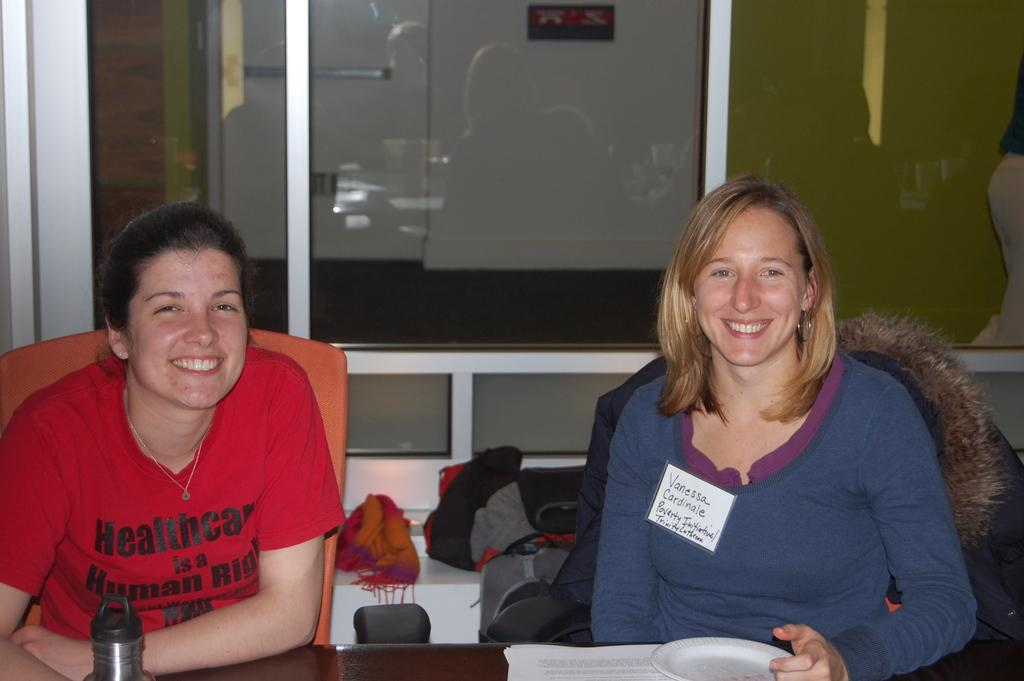How many people are in the image? There are two women in the image. What are the women doing in the image? The women are sitting at a table and posing to the camera. What type of bait is the woman on the left side of the image using? There is no bait present in the image; it features two women sitting at a table and posing to the camera. 